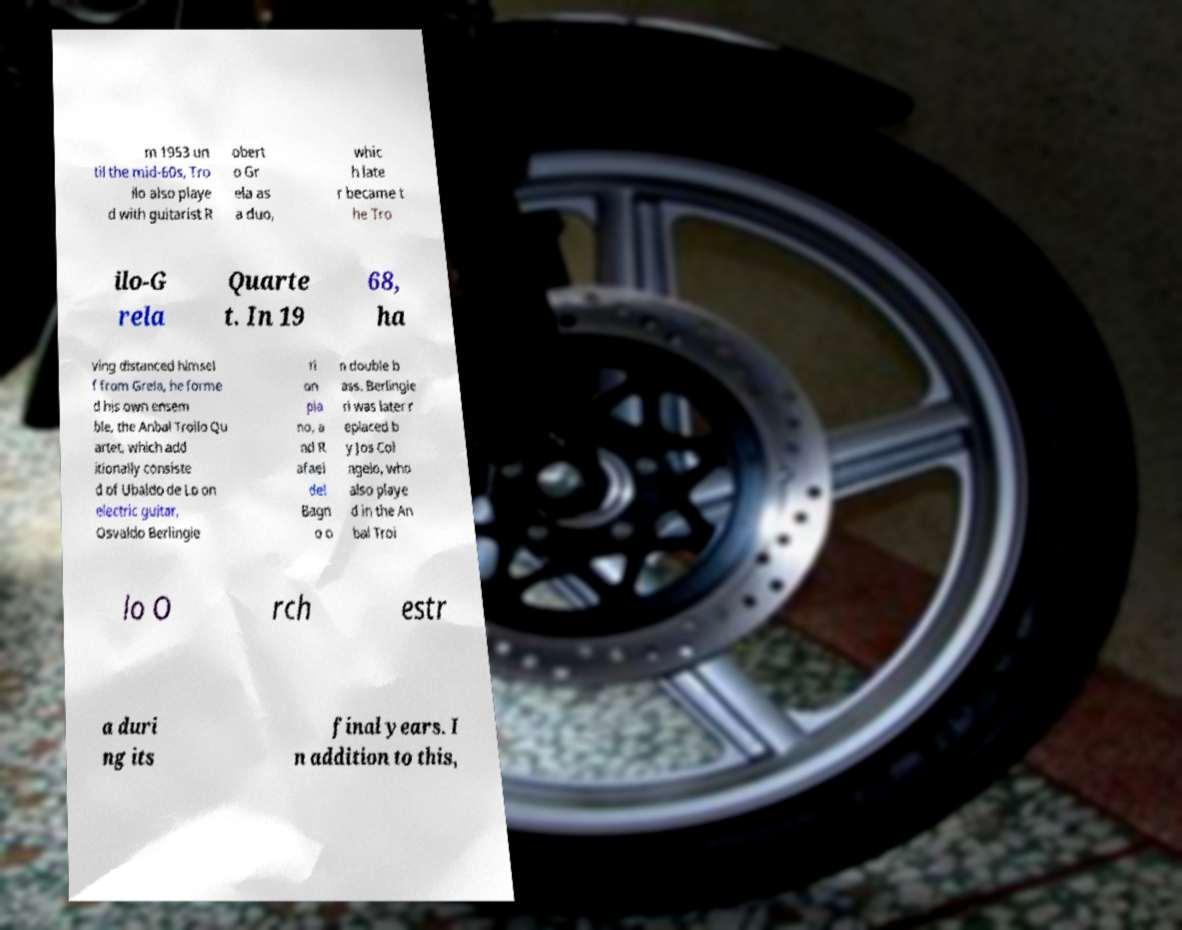Could you assist in decoding the text presented in this image and type it out clearly? m 1953 un til the mid-60s, Tro ilo also playe d with guitarist R obert o Gr ela as a duo, whic h late r became t he Tro ilo-G rela Quarte t. In 19 68, ha ving distanced himsel f from Grela, he forme d his own ensem ble, the Anbal Troilo Qu artet, which add itionally consiste d of Ubaldo de Lo on electric guitar, Osvaldo Berlingie ri on pia no, a nd R afael del Bagn o o n double b ass. Berlingie ri was later r eplaced b y Jos Col ngelo, who also playe d in the An bal Troi lo O rch estr a duri ng its final years. I n addition to this, 